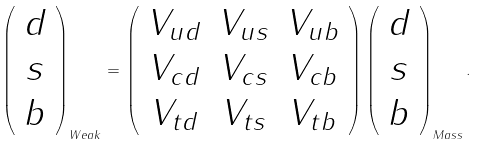Convert formula to latex. <formula><loc_0><loc_0><loc_500><loc_500>\left ( \begin{array} { c } d \\ s \\ b \end{array} \right ) _ { W e a k } = \left ( \begin{array} { c c c } V _ { u d } & V _ { u s } & V _ { u b } \\ V _ { c d } & V _ { c s } & V _ { c b } \\ V _ { t d } & V _ { t s } & V _ { t b } \end{array} \right ) \left ( \begin{array} { c } d \\ s \\ b \end{array} \right ) _ { M a s s } .</formula> 